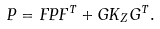<formula> <loc_0><loc_0><loc_500><loc_500>P = F P F ^ { T } + G K _ { Z } G ^ { T } .</formula> 